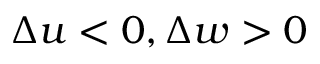Convert formula to latex. <formula><loc_0><loc_0><loc_500><loc_500>\Delta u < 0 , \Delta w > 0</formula> 